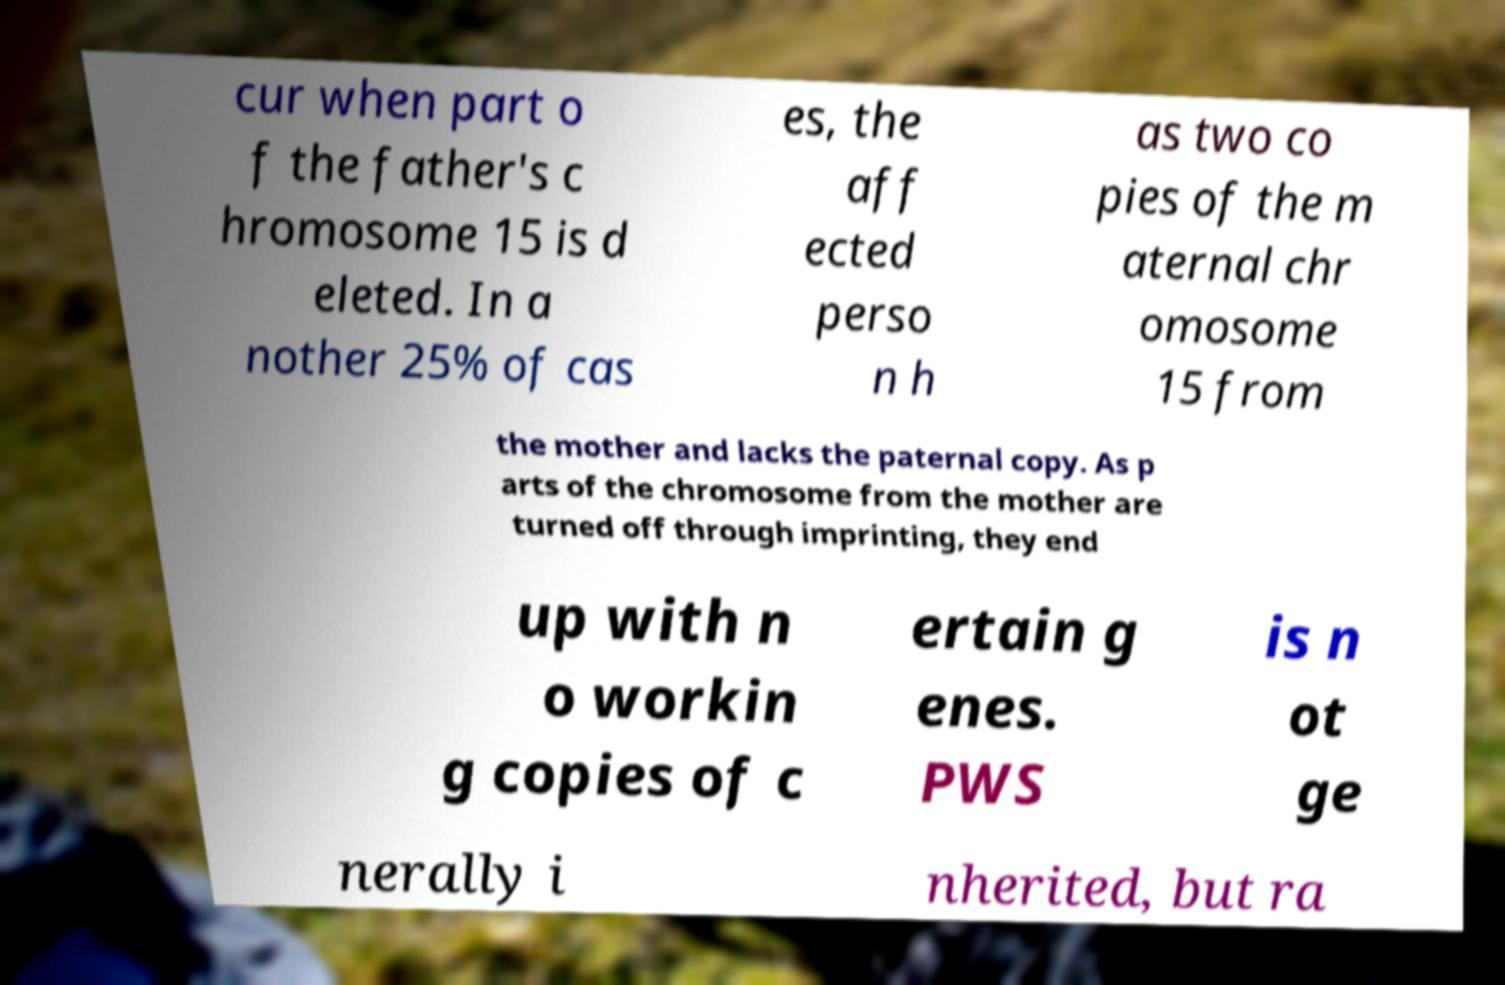Please identify and transcribe the text found in this image. cur when part o f the father's c hromosome 15 is d eleted. In a nother 25% of cas es, the aff ected perso n h as two co pies of the m aternal chr omosome 15 from the mother and lacks the paternal copy. As p arts of the chromosome from the mother are turned off through imprinting, they end up with n o workin g copies of c ertain g enes. PWS is n ot ge nerally i nherited, but ra 